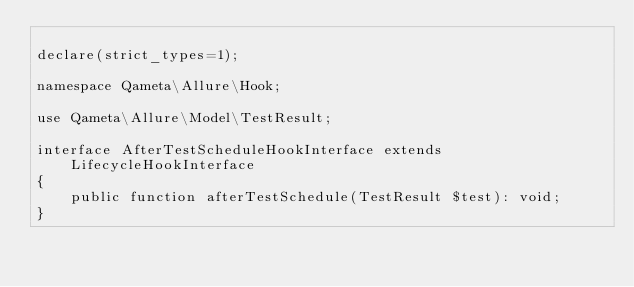Convert code to text. <code><loc_0><loc_0><loc_500><loc_500><_PHP_>
declare(strict_types=1);

namespace Qameta\Allure\Hook;

use Qameta\Allure\Model\TestResult;

interface AfterTestScheduleHookInterface extends LifecycleHookInterface
{
    public function afterTestSchedule(TestResult $test): void;
}
</code> 